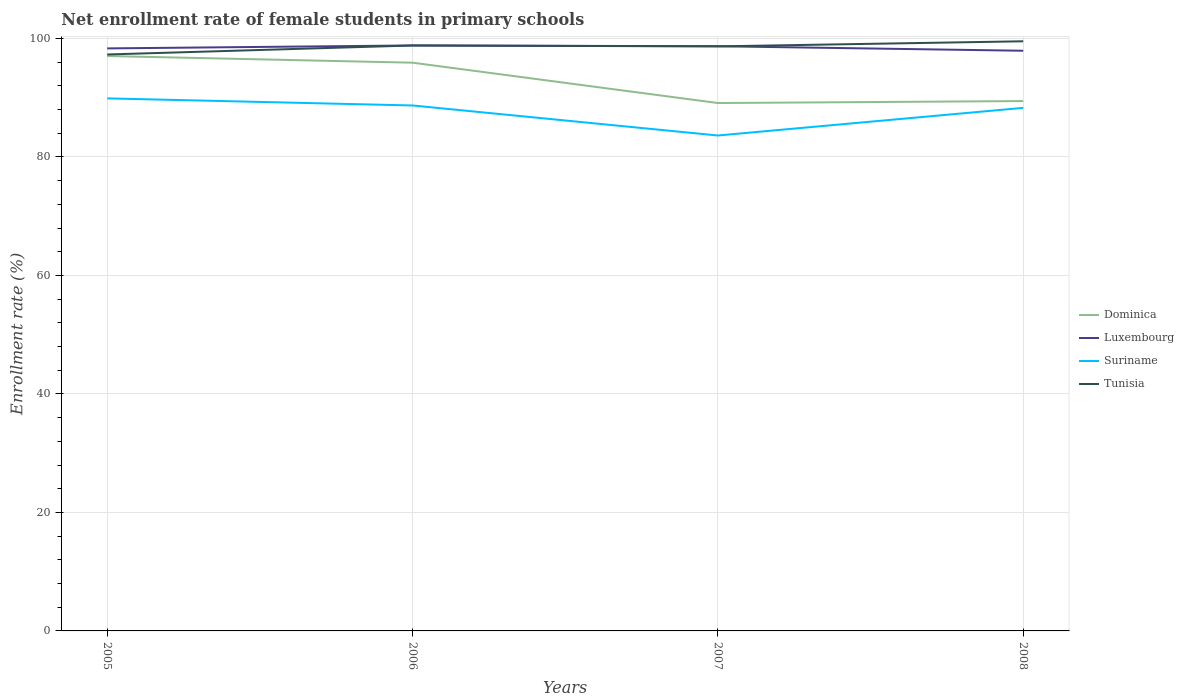How many different coloured lines are there?
Offer a terse response. 4. Does the line corresponding to Luxembourg intersect with the line corresponding to Dominica?
Your response must be concise. No. Across all years, what is the maximum net enrollment rate of female students in primary schools in Dominica?
Make the answer very short. 89.1. In which year was the net enrollment rate of female students in primary schools in Dominica maximum?
Ensure brevity in your answer.  2007. What is the total net enrollment rate of female students in primary schools in Dominica in the graph?
Offer a very short reply. -0.33. What is the difference between the highest and the second highest net enrollment rate of female students in primary schools in Tunisia?
Provide a short and direct response. 2.23. Is the net enrollment rate of female students in primary schools in Luxembourg strictly greater than the net enrollment rate of female students in primary schools in Tunisia over the years?
Your answer should be very brief. No. How are the legend labels stacked?
Your answer should be very brief. Vertical. What is the title of the graph?
Your answer should be compact. Net enrollment rate of female students in primary schools. Does "High income: nonOECD" appear as one of the legend labels in the graph?
Offer a very short reply. No. What is the label or title of the Y-axis?
Offer a terse response. Enrollment rate (%). What is the Enrollment rate (%) in Dominica in 2005?
Offer a very short reply. 97.04. What is the Enrollment rate (%) of Luxembourg in 2005?
Make the answer very short. 98.32. What is the Enrollment rate (%) in Suriname in 2005?
Offer a very short reply. 89.89. What is the Enrollment rate (%) of Tunisia in 2005?
Offer a terse response. 97.3. What is the Enrollment rate (%) of Dominica in 2006?
Make the answer very short. 95.91. What is the Enrollment rate (%) of Luxembourg in 2006?
Your response must be concise. 98.82. What is the Enrollment rate (%) of Suriname in 2006?
Your answer should be very brief. 88.69. What is the Enrollment rate (%) in Tunisia in 2006?
Offer a terse response. 98.81. What is the Enrollment rate (%) in Dominica in 2007?
Ensure brevity in your answer.  89.1. What is the Enrollment rate (%) of Luxembourg in 2007?
Keep it short and to the point. 98.69. What is the Enrollment rate (%) in Suriname in 2007?
Give a very brief answer. 83.62. What is the Enrollment rate (%) of Tunisia in 2007?
Give a very brief answer. 98.67. What is the Enrollment rate (%) in Dominica in 2008?
Provide a short and direct response. 89.43. What is the Enrollment rate (%) in Luxembourg in 2008?
Keep it short and to the point. 97.92. What is the Enrollment rate (%) of Suriname in 2008?
Provide a short and direct response. 88.29. What is the Enrollment rate (%) in Tunisia in 2008?
Ensure brevity in your answer.  99.52. Across all years, what is the maximum Enrollment rate (%) of Dominica?
Your answer should be very brief. 97.04. Across all years, what is the maximum Enrollment rate (%) of Luxembourg?
Ensure brevity in your answer.  98.82. Across all years, what is the maximum Enrollment rate (%) in Suriname?
Give a very brief answer. 89.89. Across all years, what is the maximum Enrollment rate (%) in Tunisia?
Your answer should be very brief. 99.52. Across all years, what is the minimum Enrollment rate (%) in Dominica?
Provide a succinct answer. 89.1. Across all years, what is the minimum Enrollment rate (%) in Luxembourg?
Provide a succinct answer. 97.92. Across all years, what is the minimum Enrollment rate (%) in Suriname?
Provide a succinct answer. 83.62. Across all years, what is the minimum Enrollment rate (%) of Tunisia?
Ensure brevity in your answer.  97.3. What is the total Enrollment rate (%) of Dominica in the graph?
Ensure brevity in your answer.  371.48. What is the total Enrollment rate (%) of Luxembourg in the graph?
Your answer should be compact. 393.75. What is the total Enrollment rate (%) in Suriname in the graph?
Provide a short and direct response. 350.49. What is the total Enrollment rate (%) in Tunisia in the graph?
Provide a short and direct response. 394.3. What is the difference between the Enrollment rate (%) of Dominica in 2005 and that in 2006?
Keep it short and to the point. 1.12. What is the difference between the Enrollment rate (%) of Luxembourg in 2005 and that in 2006?
Provide a succinct answer. -0.5. What is the difference between the Enrollment rate (%) in Suriname in 2005 and that in 2006?
Keep it short and to the point. 1.2. What is the difference between the Enrollment rate (%) of Tunisia in 2005 and that in 2006?
Make the answer very short. -1.52. What is the difference between the Enrollment rate (%) in Dominica in 2005 and that in 2007?
Provide a short and direct response. 7.93. What is the difference between the Enrollment rate (%) of Luxembourg in 2005 and that in 2007?
Your answer should be compact. -0.37. What is the difference between the Enrollment rate (%) of Suriname in 2005 and that in 2007?
Offer a terse response. 6.27. What is the difference between the Enrollment rate (%) in Tunisia in 2005 and that in 2007?
Your answer should be very brief. -1.37. What is the difference between the Enrollment rate (%) in Dominica in 2005 and that in 2008?
Provide a succinct answer. 7.6. What is the difference between the Enrollment rate (%) of Luxembourg in 2005 and that in 2008?
Provide a succinct answer. 0.4. What is the difference between the Enrollment rate (%) of Suriname in 2005 and that in 2008?
Provide a short and direct response. 1.6. What is the difference between the Enrollment rate (%) in Tunisia in 2005 and that in 2008?
Make the answer very short. -2.23. What is the difference between the Enrollment rate (%) of Dominica in 2006 and that in 2007?
Offer a very short reply. 6.81. What is the difference between the Enrollment rate (%) of Luxembourg in 2006 and that in 2007?
Keep it short and to the point. 0.13. What is the difference between the Enrollment rate (%) of Suriname in 2006 and that in 2007?
Keep it short and to the point. 5.07. What is the difference between the Enrollment rate (%) of Tunisia in 2006 and that in 2007?
Keep it short and to the point. 0.15. What is the difference between the Enrollment rate (%) in Dominica in 2006 and that in 2008?
Your answer should be very brief. 6.48. What is the difference between the Enrollment rate (%) of Luxembourg in 2006 and that in 2008?
Provide a short and direct response. 0.89. What is the difference between the Enrollment rate (%) in Suriname in 2006 and that in 2008?
Provide a short and direct response. 0.4. What is the difference between the Enrollment rate (%) of Tunisia in 2006 and that in 2008?
Keep it short and to the point. -0.71. What is the difference between the Enrollment rate (%) of Dominica in 2007 and that in 2008?
Offer a terse response. -0.33. What is the difference between the Enrollment rate (%) of Luxembourg in 2007 and that in 2008?
Ensure brevity in your answer.  0.76. What is the difference between the Enrollment rate (%) of Suriname in 2007 and that in 2008?
Give a very brief answer. -4.67. What is the difference between the Enrollment rate (%) of Tunisia in 2007 and that in 2008?
Provide a short and direct response. -0.86. What is the difference between the Enrollment rate (%) in Dominica in 2005 and the Enrollment rate (%) in Luxembourg in 2006?
Your answer should be very brief. -1.78. What is the difference between the Enrollment rate (%) in Dominica in 2005 and the Enrollment rate (%) in Suriname in 2006?
Provide a succinct answer. 8.35. What is the difference between the Enrollment rate (%) in Dominica in 2005 and the Enrollment rate (%) in Tunisia in 2006?
Offer a very short reply. -1.78. What is the difference between the Enrollment rate (%) of Luxembourg in 2005 and the Enrollment rate (%) of Suriname in 2006?
Keep it short and to the point. 9.63. What is the difference between the Enrollment rate (%) in Luxembourg in 2005 and the Enrollment rate (%) in Tunisia in 2006?
Offer a very short reply. -0.49. What is the difference between the Enrollment rate (%) in Suriname in 2005 and the Enrollment rate (%) in Tunisia in 2006?
Give a very brief answer. -8.93. What is the difference between the Enrollment rate (%) of Dominica in 2005 and the Enrollment rate (%) of Luxembourg in 2007?
Offer a very short reply. -1.65. What is the difference between the Enrollment rate (%) in Dominica in 2005 and the Enrollment rate (%) in Suriname in 2007?
Keep it short and to the point. 13.42. What is the difference between the Enrollment rate (%) in Dominica in 2005 and the Enrollment rate (%) in Tunisia in 2007?
Ensure brevity in your answer.  -1.63. What is the difference between the Enrollment rate (%) in Luxembourg in 2005 and the Enrollment rate (%) in Suriname in 2007?
Give a very brief answer. 14.7. What is the difference between the Enrollment rate (%) of Luxembourg in 2005 and the Enrollment rate (%) of Tunisia in 2007?
Ensure brevity in your answer.  -0.35. What is the difference between the Enrollment rate (%) in Suriname in 2005 and the Enrollment rate (%) in Tunisia in 2007?
Make the answer very short. -8.78. What is the difference between the Enrollment rate (%) in Dominica in 2005 and the Enrollment rate (%) in Luxembourg in 2008?
Make the answer very short. -0.89. What is the difference between the Enrollment rate (%) in Dominica in 2005 and the Enrollment rate (%) in Suriname in 2008?
Offer a terse response. 8.75. What is the difference between the Enrollment rate (%) in Dominica in 2005 and the Enrollment rate (%) in Tunisia in 2008?
Make the answer very short. -2.49. What is the difference between the Enrollment rate (%) of Luxembourg in 2005 and the Enrollment rate (%) of Suriname in 2008?
Ensure brevity in your answer.  10.03. What is the difference between the Enrollment rate (%) of Luxembourg in 2005 and the Enrollment rate (%) of Tunisia in 2008?
Your answer should be compact. -1.2. What is the difference between the Enrollment rate (%) of Suriname in 2005 and the Enrollment rate (%) of Tunisia in 2008?
Your answer should be very brief. -9.64. What is the difference between the Enrollment rate (%) of Dominica in 2006 and the Enrollment rate (%) of Luxembourg in 2007?
Give a very brief answer. -2.78. What is the difference between the Enrollment rate (%) in Dominica in 2006 and the Enrollment rate (%) in Suriname in 2007?
Provide a succinct answer. 12.29. What is the difference between the Enrollment rate (%) in Dominica in 2006 and the Enrollment rate (%) in Tunisia in 2007?
Offer a terse response. -2.76. What is the difference between the Enrollment rate (%) in Luxembourg in 2006 and the Enrollment rate (%) in Suriname in 2007?
Make the answer very short. 15.2. What is the difference between the Enrollment rate (%) of Luxembourg in 2006 and the Enrollment rate (%) of Tunisia in 2007?
Make the answer very short. 0.15. What is the difference between the Enrollment rate (%) in Suriname in 2006 and the Enrollment rate (%) in Tunisia in 2007?
Make the answer very short. -9.98. What is the difference between the Enrollment rate (%) of Dominica in 2006 and the Enrollment rate (%) of Luxembourg in 2008?
Offer a very short reply. -2.01. What is the difference between the Enrollment rate (%) in Dominica in 2006 and the Enrollment rate (%) in Suriname in 2008?
Ensure brevity in your answer.  7.62. What is the difference between the Enrollment rate (%) in Dominica in 2006 and the Enrollment rate (%) in Tunisia in 2008?
Your answer should be very brief. -3.61. What is the difference between the Enrollment rate (%) in Luxembourg in 2006 and the Enrollment rate (%) in Suriname in 2008?
Offer a very short reply. 10.53. What is the difference between the Enrollment rate (%) in Luxembourg in 2006 and the Enrollment rate (%) in Tunisia in 2008?
Offer a terse response. -0.7. What is the difference between the Enrollment rate (%) of Suriname in 2006 and the Enrollment rate (%) of Tunisia in 2008?
Your answer should be very brief. -10.83. What is the difference between the Enrollment rate (%) in Dominica in 2007 and the Enrollment rate (%) in Luxembourg in 2008?
Offer a very short reply. -8.82. What is the difference between the Enrollment rate (%) of Dominica in 2007 and the Enrollment rate (%) of Suriname in 2008?
Your answer should be compact. 0.81. What is the difference between the Enrollment rate (%) in Dominica in 2007 and the Enrollment rate (%) in Tunisia in 2008?
Ensure brevity in your answer.  -10.42. What is the difference between the Enrollment rate (%) in Luxembourg in 2007 and the Enrollment rate (%) in Suriname in 2008?
Ensure brevity in your answer.  10.4. What is the difference between the Enrollment rate (%) in Luxembourg in 2007 and the Enrollment rate (%) in Tunisia in 2008?
Keep it short and to the point. -0.84. What is the difference between the Enrollment rate (%) in Suriname in 2007 and the Enrollment rate (%) in Tunisia in 2008?
Ensure brevity in your answer.  -15.9. What is the average Enrollment rate (%) in Dominica per year?
Make the answer very short. 92.87. What is the average Enrollment rate (%) in Luxembourg per year?
Keep it short and to the point. 98.44. What is the average Enrollment rate (%) of Suriname per year?
Your answer should be compact. 87.62. What is the average Enrollment rate (%) of Tunisia per year?
Your answer should be very brief. 98.58. In the year 2005, what is the difference between the Enrollment rate (%) in Dominica and Enrollment rate (%) in Luxembourg?
Offer a very short reply. -1.28. In the year 2005, what is the difference between the Enrollment rate (%) in Dominica and Enrollment rate (%) in Suriname?
Give a very brief answer. 7.15. In the year 2005, what is the difference between the Enrollment rate (%) in Dominica and Enrollment rate (%) in Tunisia?
Make the answer very short. -0.26. In the year 2005, what is the difference between the Enrollment rate (%) in Luxembourg and Enrollment rate (%) in Suriname?
Make the answer very short. 8.43. In the year 2005, what is the difference between the Enrollment rate (%) in Luxembourg and Enrollment rate (%) in Tunisia?
Provide a short and direct response. 1.03. In the year 2005, what is the difference between the Enrollment rate (%) in Suriname and Enrollment rate (%) in Tunisia?
Give a very brief answer. -7.41. In the year 2006, what is the difference between the Enrollment rate (%) in Dominica and Enrollment rate (%) in Luxembourg?
Ensure brevity in your answer.  -2.91. In the year 2006, what is the difference between the Enrollment rate (%) in Dominica and Enrollment rate (%) in Suriname?
Offer a very short reply. 7.22. In the year 2006, what is the difference between the Enrollment rate (%) of Dominica and Enrollment rate (%) of Tunisia?
Make the answer very short. -2.9. In the year 2006, what is the difference between the Enrollment rate (%) in Luxembourg and Enrollment rate (%) in Suriname?
Provide a short and direct response. 10.13. In the year 2006, what is the difference between the Enrollment rate (%) in Luxembourg and Enrollment rate (%) in Tunisia?
Provide a short and direct response. 0. In the year 2006, what is the difference between the Enrollment rate (%) of Suriname and Enrollment rate (%) of Tunisia?
Offer a very short reply. -10.12. In the year 2007, what is the difference between the Enrollment rate (%) in Dominica and Enrollment rate (%) in Luxembourg?
Your answer should be compact. -9.59. In the year 2007, what is the difference between the Enrollment rate (%) in Dominica and Enrollment rate (%) in Suriname?
Give a very brief answer. 5.48. In the year 2007, what is the difference between the Enrollment rate (%) of Dominica and Enrollment rate (%) of Tunisia?
Keep it short and to the point. -9.57. In the year 2007, what is the difference between the Enrollment rate (%) of Luxembourg and Enrollment rate (%) of Suriname?
Keep it short and to the point. 15.07. In the year 2007, what is the difference between the Enrollment rate (%) in Luxembourg and Enrollment rate (%) in Tunisia?
Provide a succinct answer. 0.02. In the year 2007, what is the difference between the Enrollment rate (%) in Suriname and Enrollment rate (%) in Tunisia?
Your answer should be compact. -15.05. In the year 2008, what is the difference between the Enrollment rate (%) in Dominica and Enrollment rate (%) in Luxembourg?
Provide a short and direct response. -8.49. In the year 2008, what is the difference between the Enrollment rate (%) in Dominica and Enrollment rate (%) in Suriname?
Offer a terse response. 1.14. In the year 2008, what is the difference between the Enrollment rate (%) in Dominica and Enrollment rate (%) in Tunisia?
Provide a short and direct response. -10.09. In the year 2008, what is the difference between the Enrollment rate (%) of Luxembourg and Enrollment rate (%) of Suriname?
Your answer should be compact. 9.64. In the year 2008, what is the difference between the Enrollment rate (%) of Luxembourg and Enrollment rate (%) of Tunisia?
Provide a succinct answer. -1.6. In the year 2008, what is the difference between the Enrollment rate (%) in Suriname and Enrollment rate (%) in Tunisia?
Your answer should be very brief. -11.23. What is the ratio of the Enrollment rate (%) in Dominica in 2005 to that in 2006?
Make the answer very short. 1.01. What is the ratio of the Enrollment rate (%) in Suriname in 2005 to that in 2006?
Offer a terse response. 1.01. What is the ratio of the Enrollment rate (%) of Tunisia in 2005 to that in 2006?
Offer a very short reply. 0.98. What is the ratio of the Enrollment rate (%) of Dominica in 2005 to that in 2007?
Make the answer very short. 1.09. What is the ratio of the Enrollment rate (%) in Suriname in 2005 to that in 2007?
Provide a succinct answer. 1.07. What is the ratio of the Enrollment rate (%) of Tunisia in 2005 to that in 2007?
Offer a very short reply. 0.99. What is the ratio of the Enrollment rate (%) of Dominica in 2005 to that in 2008?
Your response must be concise. 1.08. What is the ratio of the Enrollment rate (%) in Suriname in 2005 to that in 2008?
Keep it short and to the point. 1.02. What is the ratio of the Enrollment rate (%) in Tunisia in 2005 to that in 2008?
Offer a terse response. 0.98. What is the ratio of the Enrollment rate (%) of Dominica in 2006 to that in 2007?
Offer a terse response. 1.08. What is the ratio of the Enrollment rate (%) of Suriname in 2006 to that in 2007?
Your answer should be compact. 1.06. What is the ratio of the Enrollment rate (%) of Dominica in 2006 to that in 2008?
Make the answer very short. 1.07. What is the ratio of the Enrollment rate (%) in Luxembourg in 2006 to that in 2008?
Offer a terse response. 1.01. What is the ratio of the Enrollment rate (%) in Tunisia in 2006 to that in 2008?
Provide a short and direct response. 0.99. What is the ratio of the Enrollment rate (%) in Dominica in 2007 to that in 2008?
Offer a very short reply. 1. What is the ratio of the Enrollment rate (%) of Luxembourg in 2007 to that in 2008?
Offer a very short reply. 1.01. What is the ratio of the Enrollment rate (%) of Suriname in 2007 to that in 2008?
Keep it short and to the point. 0.95. What is the difference between the highest and the second highest Enrollment rate (%) in Dominica?
Your response must be concise. 1.12. What is the difference between the highest and the second highest Enrollment rate (%) of Luxembourg?
Make the answer very short. 0.13. What is the difference between the highest and the second highest Enrollment rate (%) of Suriname?
Keep it short and to the point. 1.2. What is the difference between the highest and the second highest Enrollment rate (%) in Tunisia?
Provide a succinct answer. 0.71. What is the difference between the highest and the lowest Enrollment rate (%) in Dominica?
Give a very brief answer. 7.93. What is the difference between the highest and the lowest Enrollment rate (%) in Luxembourg?
Offer a very short reply. 0.89. What is the difference between the highest and the lowest Enrollment rate (%) in Suriname?
Your answer should be very brief. 6.27. What is the difference between the highest and the lowest Enrollment rate (%) in Tunisia?
Keep it short and to the point. 2.23. 